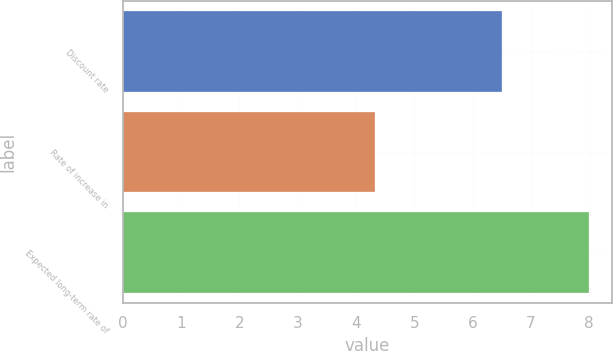<chart> <loc_0><loc_0><loc_500><loc_500><bar_chart><fcel>Discount rate<fcel>Rate of increase in<fcel>Expected long-term rate of<nl><fcel>6.5<fcel>4.33<fcel>8<nl></chart> 